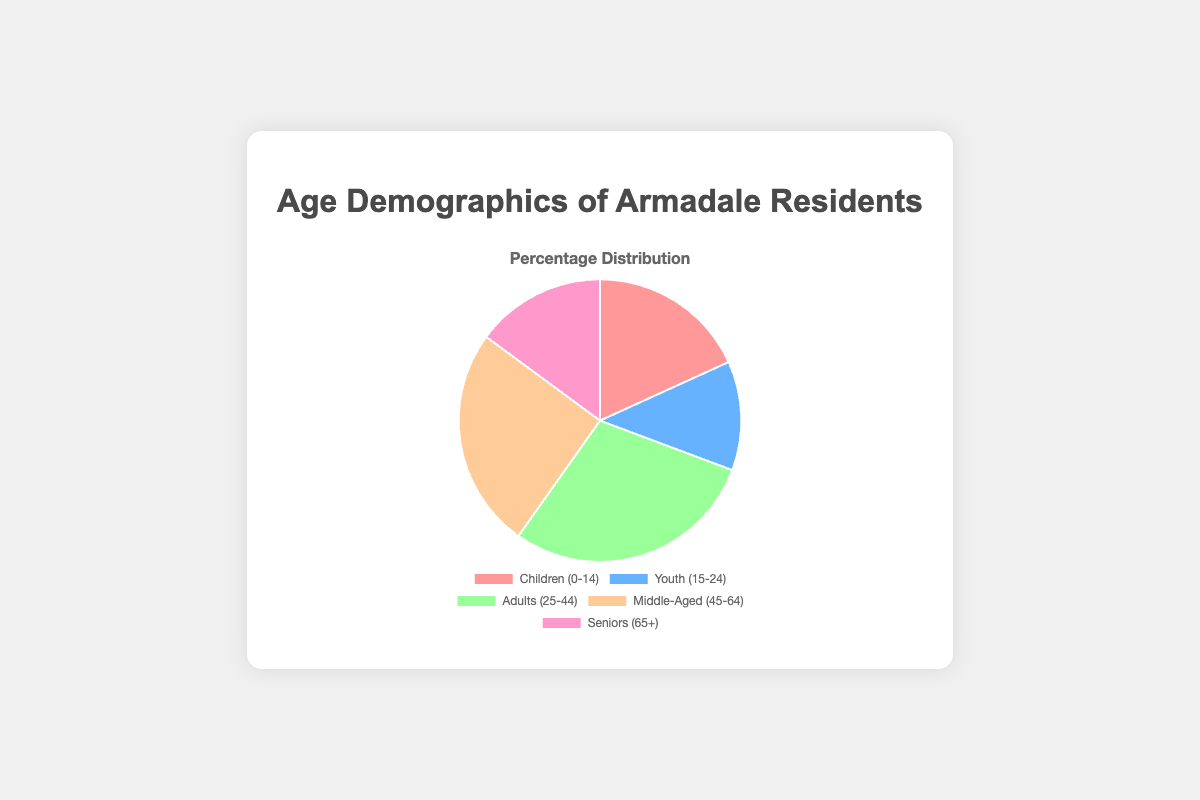What percentage of Armadale residents are either Children or Seniors? Sum the percentages of Children (0-14) and Seniors (65+): 18.2% (Children) + 14.9% (Seniors) = 33.1%
Answer: 33.1% Which age group has the largest representation among Armadale residents? The Adults (25-44) group has the largest percentage at 29.1% as shown in the pie chart.
Answer: Adults (25-44) How much larger is the percentage of Adults compared to Youth? Subtract the percentage of Youth (15-24) from the percentage of Adults (25-44): 29.1% (Adults) - 12.5% (Youth) = 16.6%
Answer: 16.6% What is the combined percentage of the Middle-Aged and Senior populations? Sum the percentages of Middle-Aged (45-64) and Seniors (65+): 25.3% (Middle-Aged) + 14.9% (Seniors) = 40.2%
Answer: 40.2% Which color segment represents the Youth population, and what is its percentage? The Youth (15-24) segment is represented by the blue color with a percentage of 12.5%.
Answer: Blue, 12.5% Is the percentage of Middle-Aged residents greater than the combined percentage of Children and Youth? Compare the percentage of Middle-Aged (25.3%) with the sum of Children (18.2%) and Youth (12.5%): 18.2% + 12.5% = 30.7%. Since 25.3% < 30.7%, the answer is no.
Answer: No By how much does the percentage of Children exceed the percentage of Youth? Subtract the percentage of Youth (15-24) from the percentage of Children (0-14): 18.2% (Children) - 12.5% (Youth) = 5.7%
Answer: 5.7% Which age group is represented by the pink color, and what percentage does it hold? The Children (0-14) are represented by the pink color, holding 18.2%.
Answer: Pink, 18.2% What is the difference between the percentages of the Middle-Aged and Seniors? Subtract the percentage of Seniors (65+) from that of the Middle-Aged (45-64): 25.3% (Middle-Aged) - 14.9% (Seniors) = 10.4%
Answer: 10.4% What is the average percentage of the age groups Children, Youth, and Adults? Sum the percentages of Children (18.2%), Youth (12.5%), and Adults (29.1%) and divide by 3: (18.2% + 12.5% + 29.1%) / 3 = 59.8% / 3 = 19.93%
Answer: 19.93% 